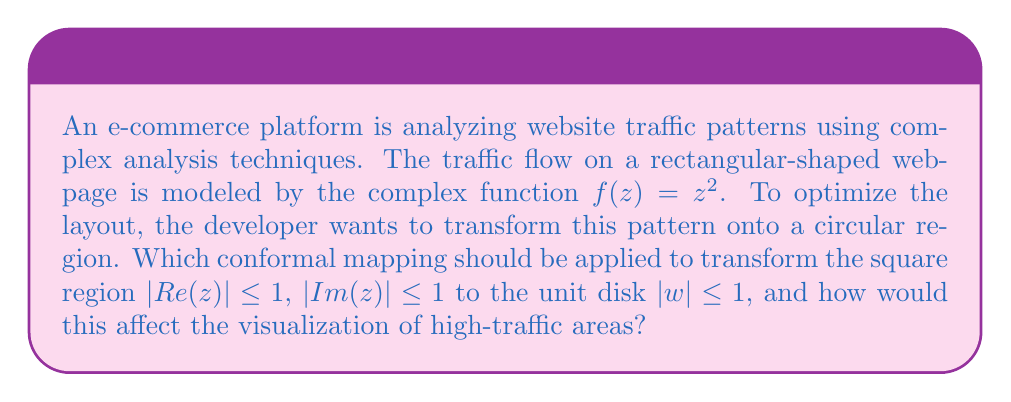Can you answer this question? To solve this problem, we need to follow these steps:

1) The appropriate conformal mapping to transform a square to a circle is the Schwarz-Christoffel mapping. Specifically, we can use the Joukowski transformation, which is a special case of the Schwarz-Christoffel mapping.

2) The Joukowski transformation is given by:

   $$w = \frac{z + \frac{1}{z}}{2}$$

3) To map the square $|Re(z)| \leq 1$, $|Im(z)| \leq 1$ to the unit disk $|w| \leq 1$, we need to first map the square to the exterior of the unit circle. This can be done by scaling and rotating the square:

   $$z' = \frac{1+i}{\sqrt{2}}z$$

4) Then, we apply the inverse Joukowski transformation:

   $$w = z' + \sqrt{z'^2 - 1}$$

5) The composition of these transformations will map the square to the unit disk.

6) Now, let's consider how this affects the visualization of high-traffic areas:

   - The original function $f(z) = z^2$ maps lines parallel to the axes into parabolas.
   - High-traffic areas in the original square layout would correspond to regions where $|f(z)|$ is large.
   - After the conformal mapping, these high-traffic areas will be preserved in shape locally (due to the conformal property), but globally they will be distorted.
   - Specifically, the corners of the square, which map to the boundary of the circle, will be "stretched out", while the center of the square will be "compressed" towards the center of the circle.

7) This transformation allows the developer to visualize the traffic patterns in a circular layout while preserving local angles and shapes. High-traffic areas near the edges of the original rectangular layout will appear spread out along the circumference of the circle, while central areas will be more condensed.
Answer: The Joukowski transformation, composed with an initial scaling and rotation, should be applied to transform the square region to the unit disk. This will preserve local traffic pattern shapes while globally distorting the visualization, spreading edge patterns along the circle's circumference and condensing central patterns towards the circle's center. 